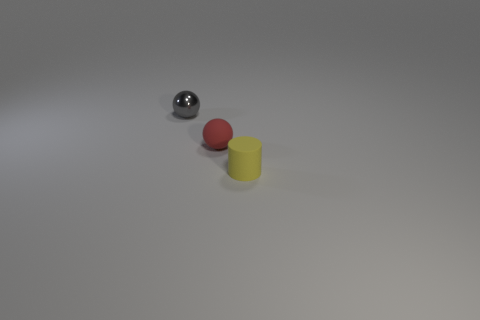Add 3 large cyan rubber spheres. How many objects exist? 6 Subtract all spheres. How many objects are left? 1 Add 1 tiny rubber cubes. How many tiny rubber cubes exist? 1 Subtract 1 gray balls. How many objects are left? 2 Subtract all metal blocks. Subtract all tiny gray objects. How many objects are left? 2 Add 3 gray balls. How many gray balls are left? 4 